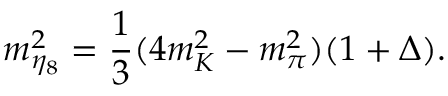Convert formula to latex. <formula><loc_0><loc_0><loc_500><loc_500>m _ { \eta _ { 8 } } ^ { 2 } = \frac { 1 } { 3 } ( 4 m _ { K } ^ { 2 } - m _ { \pi } ^ { 2 } ) ( 1 + \Delta ) .</formula> 